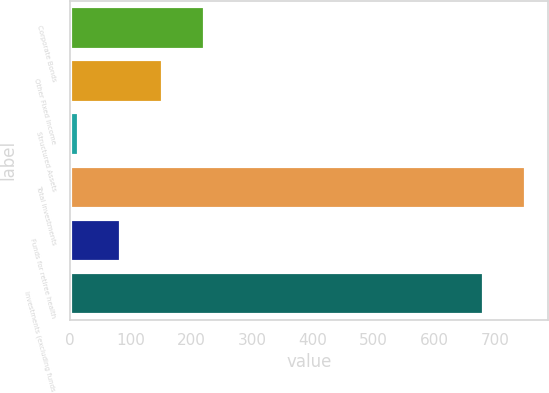Convert chart to OTSL. <chart><loc_0><loc_0><loc_500><loc_500><bar_chart><fcel>Corporate Bonds<fcel>Other Fixed Income<fcel>Structured Assets<fcel>Total investments<fcel>Funds for retiree health<fcel>Investments (excluding funds<nl><fcel>221.5<fcel>152<fcel>13<fcel>749.5<fcel>82.5<fcel>680<nl></chart> 